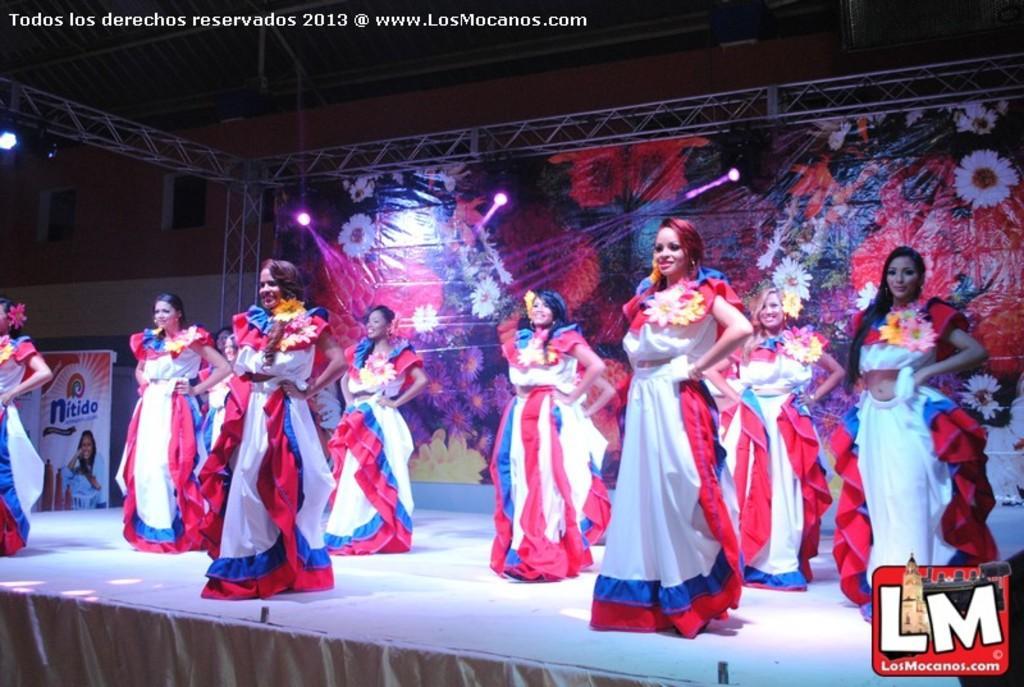In one or two sentences, can you explain what this image depicts? In this picture we can see group of people on the stage, they wore costumes, behind them we can find few metal rods, hoardings and lights, in the top left hand corner of the image we can find some text, in the bottom right hand corner we can see a logo. 